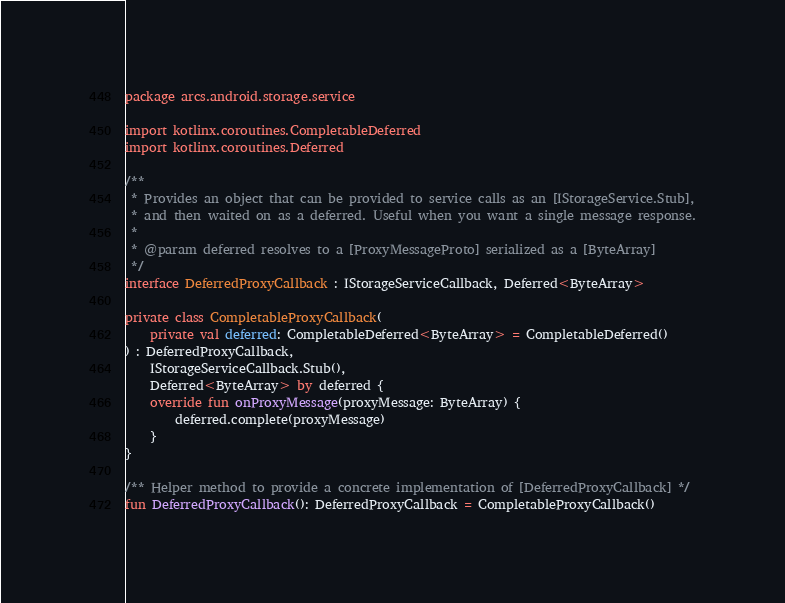Convert code to text. <code><loc_0><loc_0><loc_500><loc_500><_Kotlin_>package arcs.android.storage.service

import kotlinx.coroutines.CompletableDeferred
import kotlinx.coroutines.Deferred

/**
 * Provides an object that can be provided to service calls as an [IStorageService.Stub],
 * and then waited on as a deferred. Useful when you want a single message response.
 *
 * @param deferred resolves to a [ProxyMessageProto] serialized as a [ByteArray]
 */
interface DeferredProxyCallback : IStorageServiceCallback, Deferred<ByteArray>

private class CompletableProxyCallback(
    private val deferred: CompletableDeferred<ByteArray> = CompletableDeferred()
) : DeferredProxyCallback,
    IStorageServiceCallback.Stub(),
    Deferred<ByteArray> by deferred {
    override fun onProxyMessage(proxyMessage: ByteArray) {
        deferred.complete(proxyMessage)
    }
}

/** Helper method to provide a concrete implementation of [DeferredProxyCallback] */
fun DeferredProxyCallback(): DeferredProxyCallback = CompletableProxyCallback()
</code> 